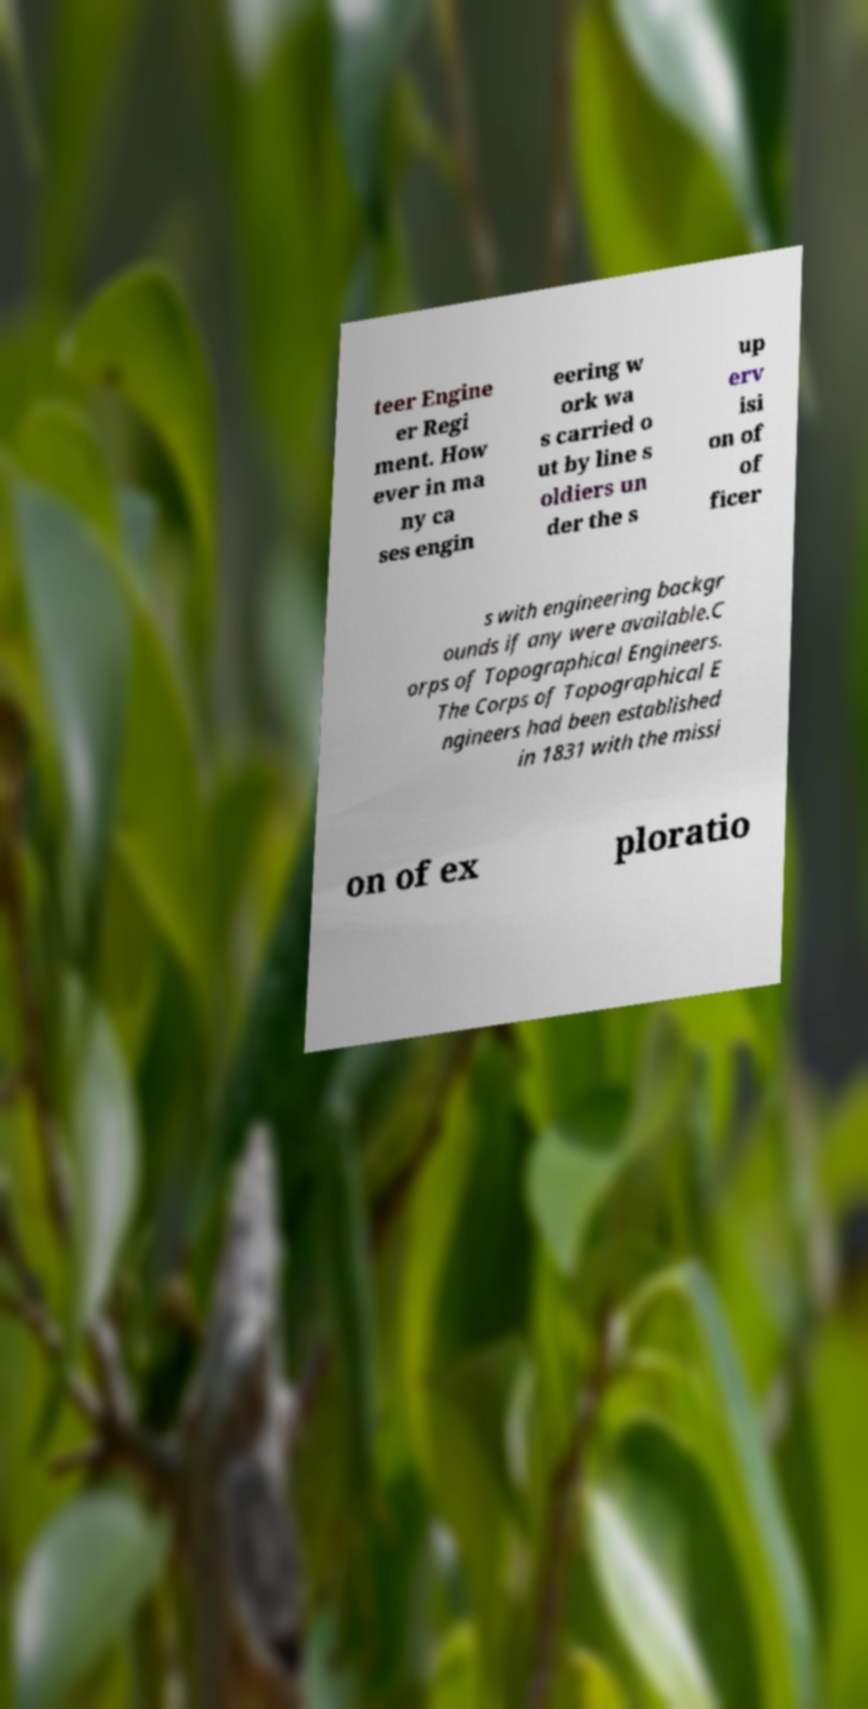Please read and relay the text visible in this image. What does it say? teer Engine er Regi ment. How ever in ma ny ca ses engin eering w ork wa s carried o ut by line s oldiers un der the s up erv isi on of of ficer s with engineering backgr ounds if any were available.C orps of Topographical Engineers. The Corps of Topographical E ngineers had been established in 1831 with the missi on of ex ploratio 